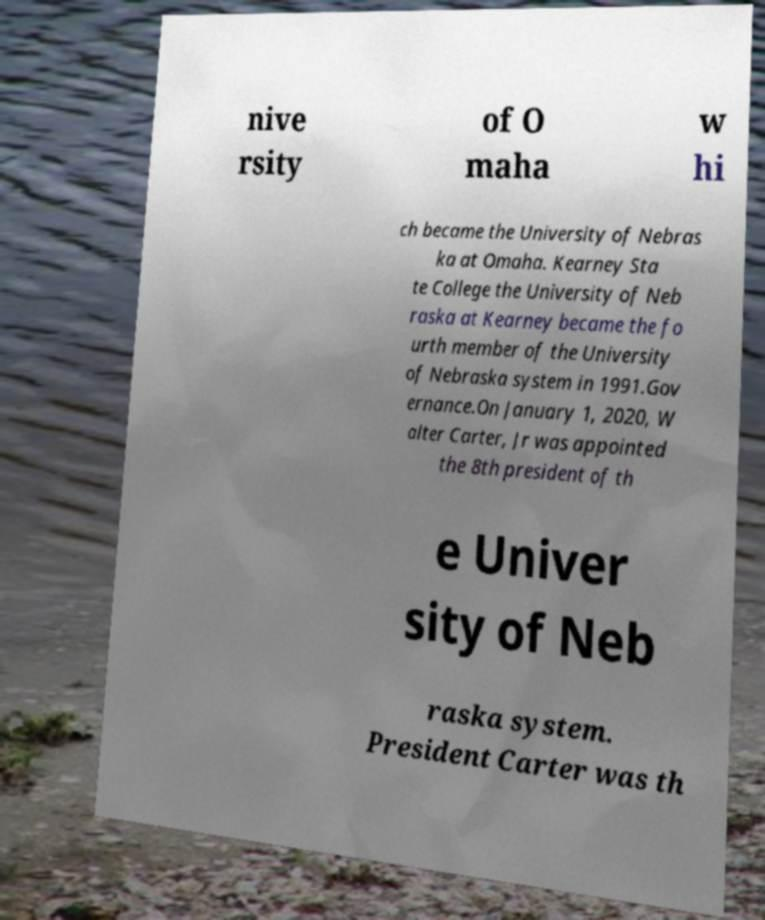Can you accurately transcribe the text from the provided image for me? nive rsity of O maha w hi ch became the University of Nebras ka at Omaha. Kearney Sta te College the University of Neb raska at Kearney became the fo urth member of the University of Nebraska system in 1991.Gov ernance.On January 1, 2020, W alter Carter, Jr was appointed the 8th president of th e Univer sity of Neb raska system. President Carter was th 